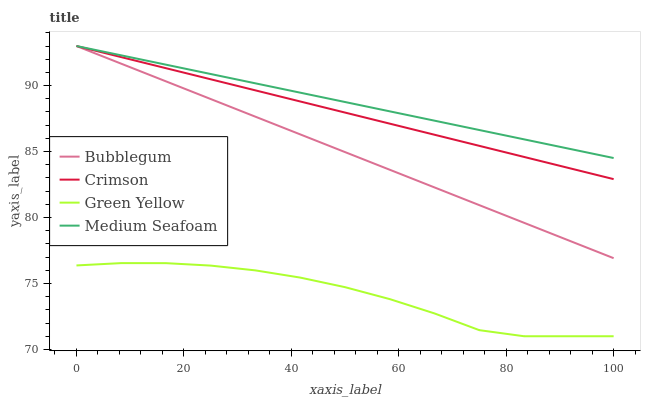Does Green Yellow have the minimum area under the curve?
Answer yes or no. Yes. Does Medium Seafoam have the maximum area under the curve?
Answer yes or no. Yes. Does Medium Seafoam have the minimum area under the curve?
Answer yes or no. No. Does Green Yellow have the maximum area under the curve?
Answer yes or no. No. Is Bubblegum the smoothest?
Answer yes or no. Yes. Is Green Yellow the roughest?
Answer yes or no. Yes. Is Medium Seafoam the smoothest?
Answer yes or no. No. Is Medium Seafoam the roughest?
Answer yes or no. No. Does Green Yellow have the lowest value?
Answer yes or no. Yes. Does Medium Seafoam have the lowest value?
Answer yes or no. No. Does Bubblegum have the highest value?
Answer yes or no. Yes. Does Green Yellow have the highest value?
Answer yes or no. No. Is Green Yellow less than Bubblegum?
Answer yes or no. Yes. Is Crimson greater than Green Yellow?
Answer yes or no. Yes. Does Medium Seafoam intersect Crimson?
Answer yes or no. Yes. Is Medium Seafoam less than Crimson?
Answer yes or no. No. Is Medium Seafoam greater than Crimson?
Answer yes or no. No. Does Green Yellow intersect Bubblegum?
Answer yes or no. No. 